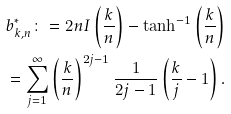Convert formula to latex. <formula><loc_0><loc_0><loc_500><loc_500>b ^ { * } _ { k , n } \colon = 2 n I \left ( \frac { k } { n } \right ) - \tanh ^ { - 1 } \left ( \frac { k } { n } \right ) \\ = \sum _ { j = 1 } ^ { \infty } \left ( \frac { k } { n } \right ) ^ { 2 j - 1 } \frac { 1 } { 2 j - 1 } \left ( \frac { k } { j } - 1 \right ) .</formula> 